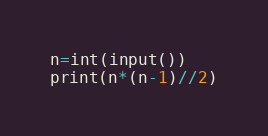<code> <loc_0><loc_0><loc_500><loc_500><_Python_>n=int(input())
print(n*(n-1)//2)</code> 